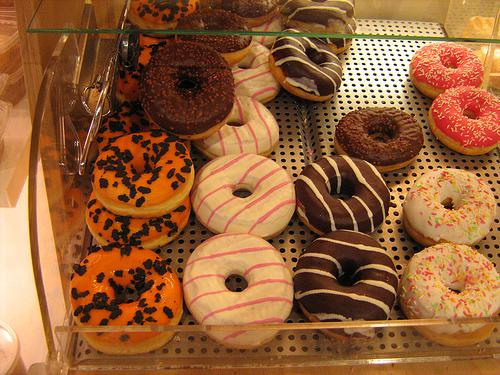Question: how many pink striped donuts are there?
Choices:
A. Five.
B. Zero.
C. Two.
D. One.
Answer with the letter. Answer: A Question: what is on the orange donuts?
Choices:
A. Chocolate sprinkles.
B. Red candies.
C. Purple sprinkles.
D. Yellow frosting.
Answer with the letter. Answer: A Question: who makes these?
Choices:
A. Woman.
B. Man.
C. The baker.
D. Teenage.
Answer with the letter. Answer: C Question: when might you eat these?
Choices:
A. Afternoon.
B. In the morning.
C. Evening.
D. Sunset.
Answer with the letter. Answer: B Question: what are these?
Choices:
A. Cupcakes.
B. Cookies.
C. Donuts.
D. Brownies.
Answer with the letter. Answer: C Question: where would you find these donuts?
Choices:
A. At a bakery.
B. Grocery.
C. Coffee Shop.
D. Cafe.
Answer with the letter. Answer: A 